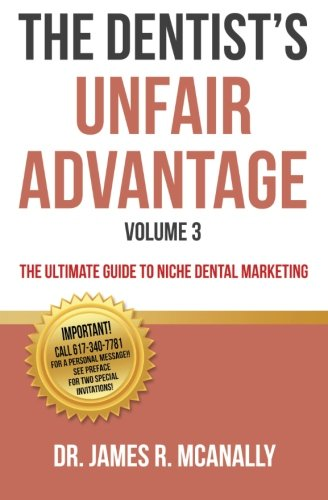Who is the author of this book? The book's author is Dr. James R. McAnally, who has penned this comprehensive guide on dental marketing. 